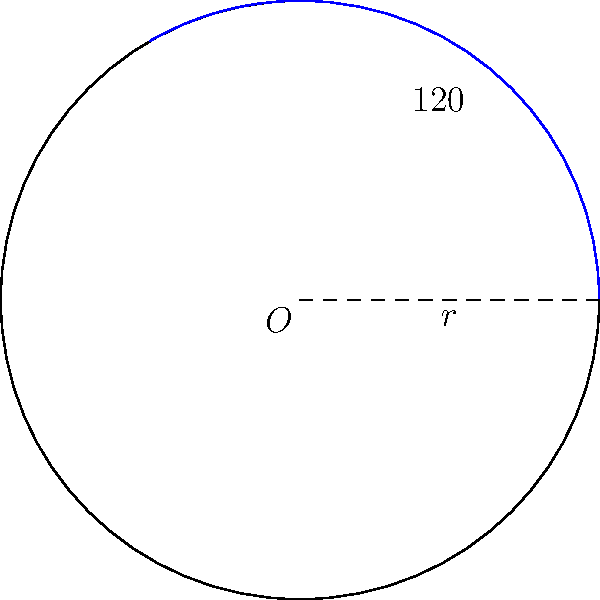At a star-studded Hollywood party, you're tasked with arranging a circular table for a scene. The table has a radius of 10 feet, and you need to section off an area for the lead actors, covering an angle of 120°. What is the area of this sector in square feet? (Use $\pi = 3.14$ for calculations) To find the area of a sector, we'll follow these steps:

1) The formula for the area of a sector is:
   $A = \frac{1}{2}r^2\theta$
   Where $r$ is the radius and $\theta$ is the angle in radians.

2) We're given the angle in degrees (120°), so we need to convert it to radians:
   $\theta = 120° \times \frac{\pi}{180°} = \frac{2\pi}{3}$ radians

3) Now we can plug our values into the formula:
   $A = \frac{1}{2} \times 10^2 \times \frac{2\pi}{3}$

4) Simplify:
   $A = \frac{100\pi}{3}$

5) Using $\pi = 3.14$:
   $A = \frac{100 \times 3.14}{3} = 104.67$ square feet

Therefore, the area of the sector for the lead actors is approximately 104.67 square feet.
Answer: 104.67 sq ft 